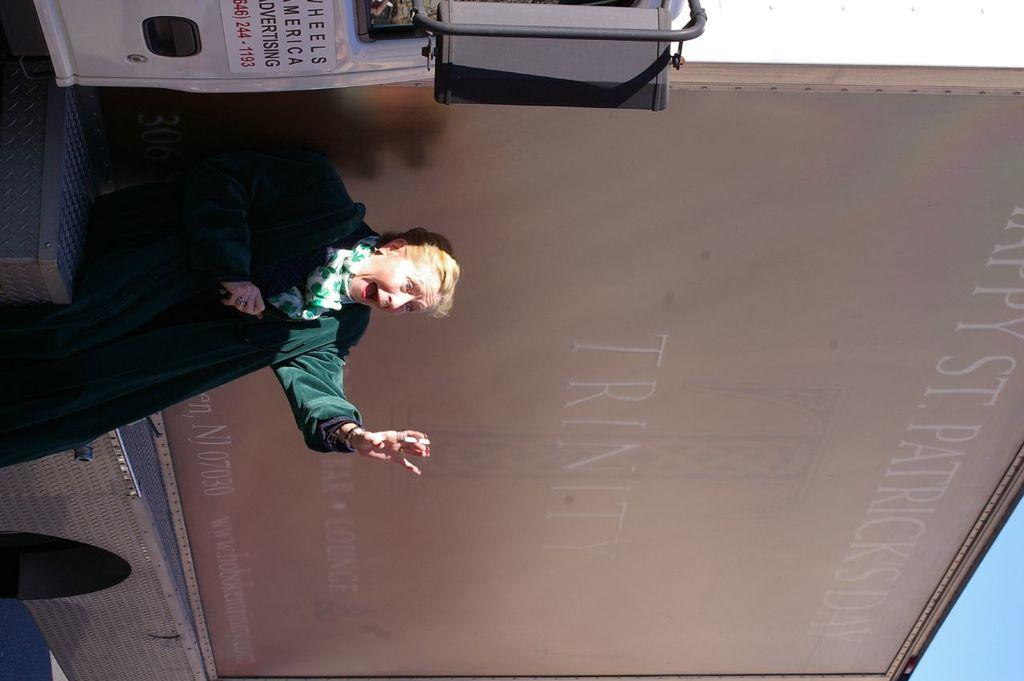What is the main subject of the image? There is a woman standing in the image. What is located behind the woman in the image? There is a poster with text behind the woman. Can you describe the objects visible in the image? There are objects visible in the image, but their specific details are not mentioned in the facts. What can be seen beneath the woman's feet in the image? The ground is visible in the image. What is visible above the woman's head in the image? The sky is visible in the image. How many sisters does the woman have in the image? There is no information about the woman's sisters in the image or the provided facts. What type of beetle can be seen crawling on the woman's shoulder in the image? There is no beetle present in the image. 